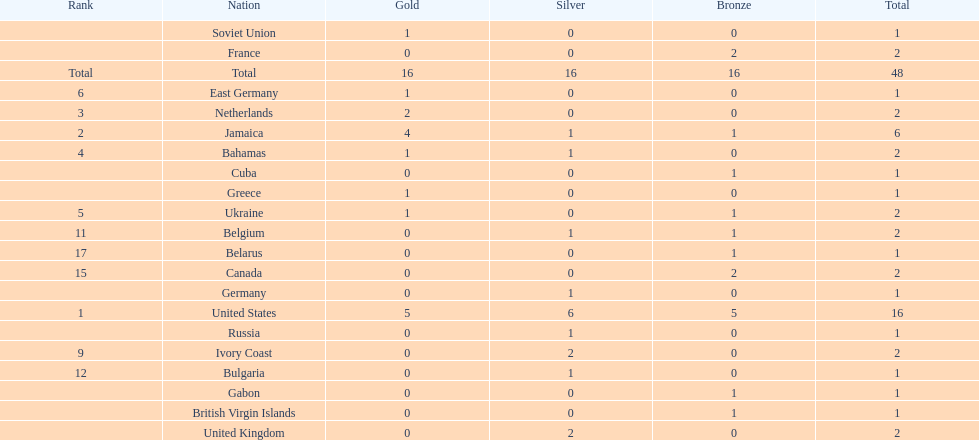What is the total number of gold medals won by jamaica? 4. 